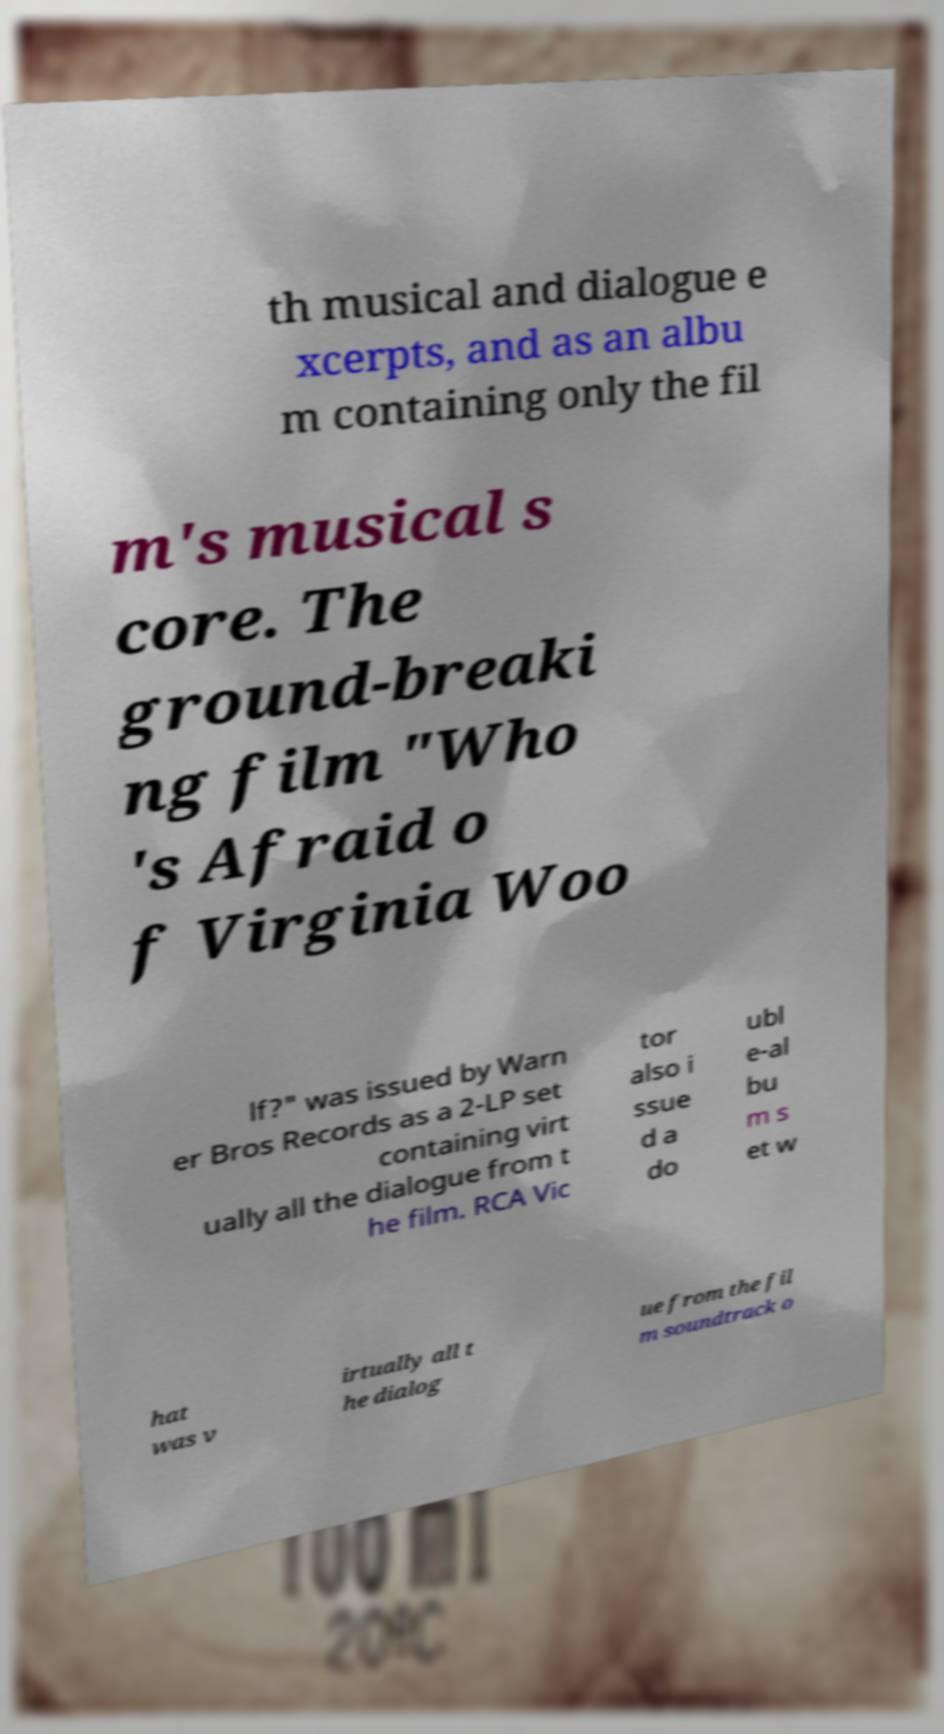Could you extract and type out the text from this image? th musical and dialogue e xcerpts, and as an albu m containing only the fil m's musical s core. The ground-breaki ng film "Who 's Afraid o f Virginia Woo lf?" was issued by Warn er Bros Records as a 2-LP set containing virt ually all the dialogue from t he film. RCA Vic tor also i ssue d a do ubl e-al bu m s et w hat was v irtually all t he dialog ue from the fil m soundtrack o 